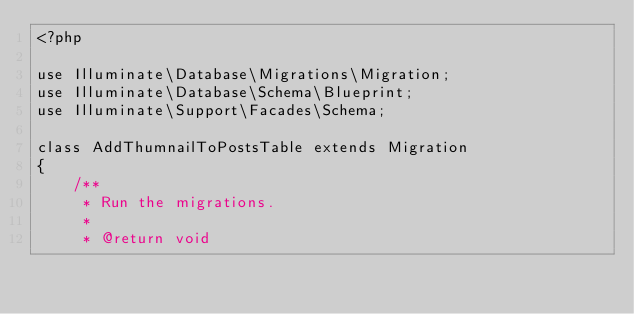<code> <loc_0><loc_0><loc_500><loc_500><_PHP_><?php

use Illuminate\Database\Migrations\Migration;
use Illuminate\Database\Schema\Blueprint;
use Illuminate\Support\Facades\Schema;

class AddThumnailToPostsTable extends Migration
{
    /**
     * Run the migrations.
     *
     * @return void</code> 